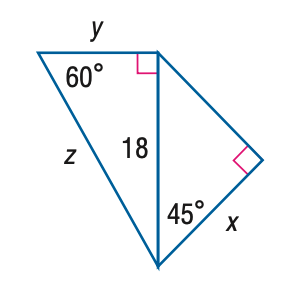Answer the mathemtical geometry problem and directly provide the correct option letter.
Question: Find z.
Choices: A: 6 \sqrt { 3 } B: 12 \sqrt { 3 } C: 18 \sqrt { 2 } D: 36 B 